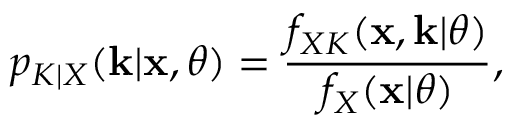Convert formula to latex. <formula><loc_0><loc_0><loc_500><loc_500>p _ { K | X } ( \mathbf k | \mathbf x , \theta ) = \frac { f _ { X K } ( \mathbf x , \mathbf k | \theta ) } { f _ { X } ( \mathbf x | \theta ) } ,</formula> 